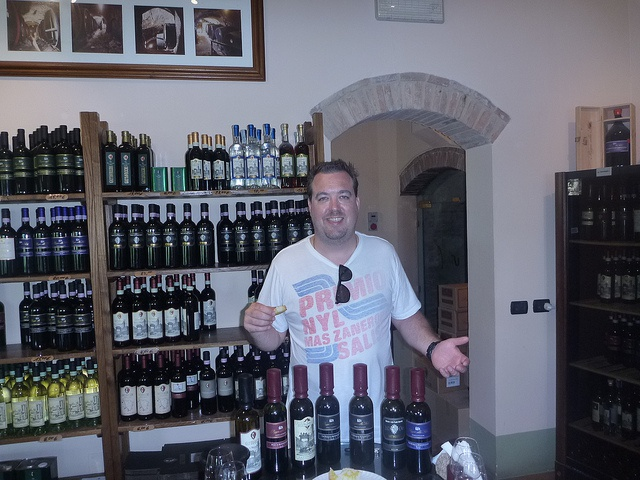Describe the objects in this image and their specific colors. I can see people in gray, darkgray, and lavender tones, bottle in gray, black, and purple tones, bottle in gray, black, purple, lightblue, and darkgray tones, bottle in gray, black, navy, purple, and blue tones, and bottle in gray, navy, black, and purple tones in this image. 